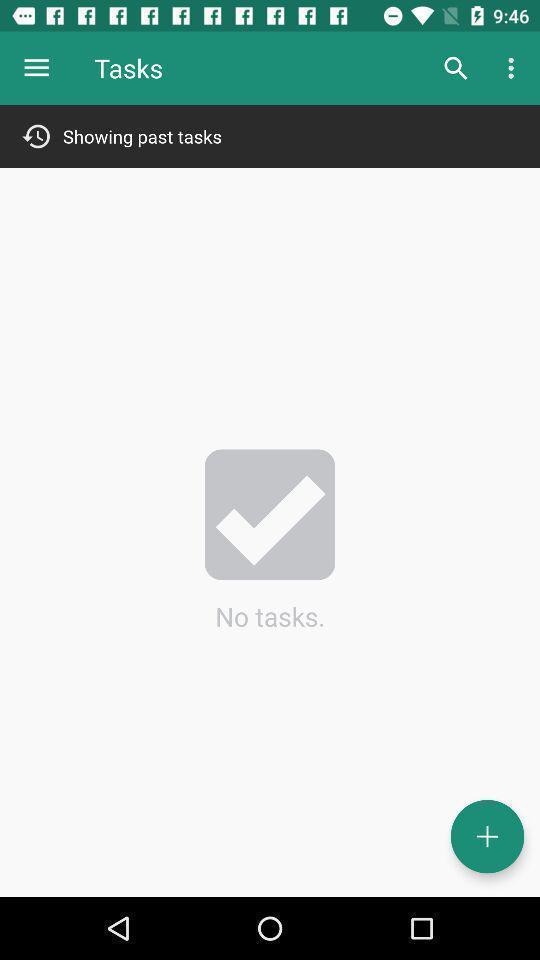Provide a description of this screenshot. Showing information of past tasks in the app. 